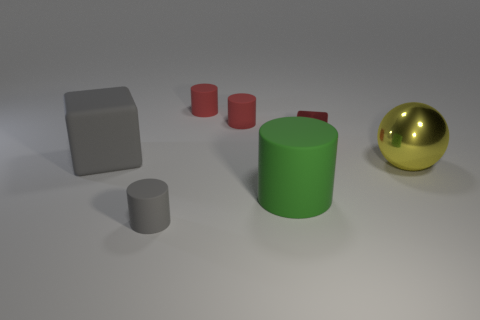Add 2 gray matte blocks. How many objects exist? 9 Subtract all blocks. How many objects are left? 5 Subtract all big gray blocks. Subtract all red metal things. How many objects are left? 5 Add 4 tiny cubes. How many tiny cubes are left? 5 Add 4 tiny gray matte things. How many tiny gray matte things exist? 5 Subtract 0 purple spheres. How many objects are left? 7 